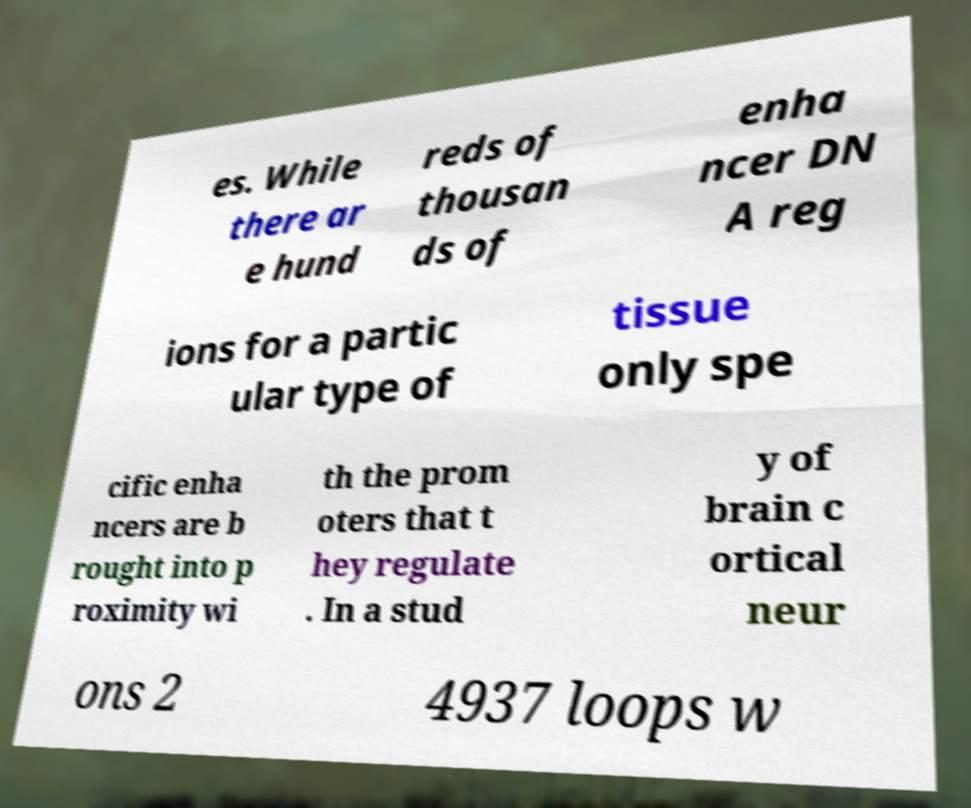Can you accurately transcribe the text from the provided image for me? es. While there ar e hund reds of thousan ds of enha ncer DN A reg ions for a partic ular type of tissue only spe cific enha ncers are b rought into p roximity wi th the prom oters that t hey regulate . In a stud y of brain c ortical neur ons 2 4937 loops w 